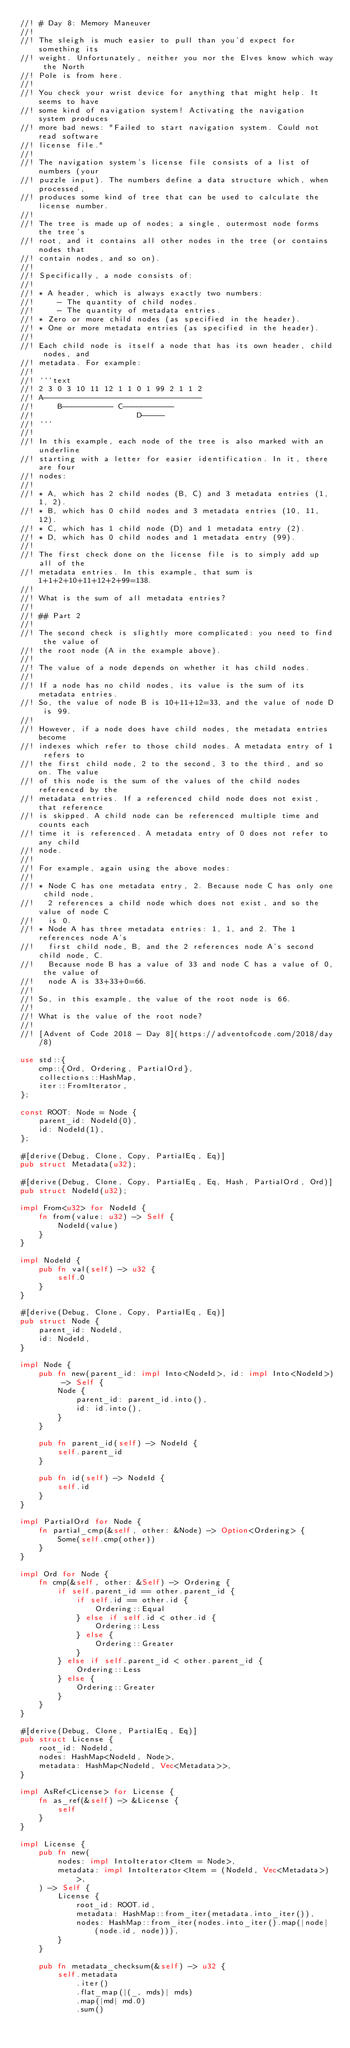<code> <loc_0><loc_0><loc_500><loc_500><_Rust_>//! # Day 8: Memory Maneuver
//!
//! The sleigh is much easier to pull than you'd expect for something its
//! weight. Unfortunately, neither you nor the Elves know which way the North
//! Pole is from here.
//!
//! You check your wrist device for anything that might help. It seems to have
//! some kind of navigation system! Activating the navigation system produces
//! more bad news: "Failed to start navigation system. Could not read software
//! license file."
//!
//! The navigation system's license file consists of a list of numbers (your
//! puzzle input). The numbers define a data structure which, when processed,
//! produces some kind of tree that can be used to calculate the license number.
//!
//! The tree is made up of nodes; a single, outermost node forms the tree's
//! root, and it contains all other nodes in the tree (or contains nodes that
//! contain nodes, and so on).
//!
//! Specifically, a node consists of:
//!
//! * A header, which is always exactly two numbers:
//!     - The quantity of child nodes.
//!     - The quantity of metadata entries.
//! * Zero or more child nodes (as specified in the header).
//! * One or more metadata entries (as specified in the header).
//!
//! Each child node is itself a node that has its own header, child nodes, and
//! metadata. For example:
//!
//! ```text
//! 2 3 0 3 10 11 12 1 1 0 1 99 2 1 1 2
//! A----------------------------------
//!     B----------- C-----------
//!                      D-----
//! ```
//!
//! In this example, each node of the tree is also marked with an underline
//! starting with a letter for easier identification. In it, there are four
//! nodes:
//!
//! * A, which has 2 child nodes (B, C) and 3 metadata entries (1, 1, 2).
//! * B, which has 0 child nodes and 3 metadata entries (10, 11, 12).
//! * C, which has 1 child node (D) and 1 metadata entry (2).
//! * D, which has 0 child nodes and 1 metadata entry (99).
//!
//! The first check done on the license file is to simply add up all of the
//! metadata entries. In this example, that sum is 1+1+2+10+11+12+2+99=138.
//!
//! What is the sum of all metadata entries?
//!
//! ## Part 2
//!
//! The second check is slightly more complicated: you need to find the value of
//! the root node (A in the example above).
//!
//! The value of a node depends on whether it has child nodes.
//!
//! If a node has no child nodes, its value is the sum of its metadata entries.
//! So, the value of node B is 10+11+12=33, and the value of node D is 99.
//!
//! However, if a node does have child nodes, the metadata entries become
//! indexes which refer to those child nodes. A metadata entry of 1 refers to
//! the first child node, 2 to the second, 3 to the third, and so on. The value
//! of this node is the sum of the values of the child nodes referenced by the
//! metadata entries. If a referenced child node does not exist, that reference
//! is skipped. A child node can be referenced multiple time and counts each
//! time it is referenced. A metadata entry of 0 does not refer to any child
//! node.
//!
//! For example, again using the above nodes:
//!
//! * Node C has one metadata entry, 2. Because node C has only one child node,
//!   2 references a child node which does not exist, and so the value of node C
//!   is 0.
//! * Node A has three metadata entries: 1, 1, and 2. The 1 references node A's
//!   first child node, B, and the 2 references node A's second child node, C.
//!   Because node B has a value of 33 and node C has a value of 0, the value of
//!   node A is 33+33+0=66.
//!
//! So, in this example, the value of the root node is 66.
//!
//! What is the value of the root node?
//!
//! [Advent of Code 2018 - Day 8](https://adventofcode.com/2018/day/8)

use std::{
    cmp::{Ord, Ordering, PartialOrd},
    collections::HashMap,
    iter::FromIterator,
};

const ROOT: Node = Node {
    parent_id: NodeId(0),
    id: NodeId(1),
};

#[derive(Debug, Clone, Copy, PartialEq, Eq)]
pub struct Metadata(u32);

#[derive(Debug, Clone, Copy, PartialEq, Eq, Hash, PartialOrd, Ord)]
pub struct NodeId(u32);

impl From<u32> for NodeId {
    fn from(value: u32) -> Self {
        NodeId(value)
    }
}

impl NodeId {
    pub fn val(self) -> u32 {
        self.0
    }
}

#[derive(Debug, Clone, Copy, PartialEq, Eq)]
pub struct Node {
    parent_id: NodeId,
    id: NodeId,
}

impl Node {
    pub fn new(parent_id: impl Into<NodeId>, id: impl Into<NodeId>) -> Self {
        Node {
            parent_id: parent_id.into(),
            id: id.into(),
        }
    }

    pub fn parent_id(self) -> NodeId {
        self.parent_id
    }

    pub fn id(self) -> NodeId {
        self.id
    }
}

impl PartialOrd for Node {
    fn partial_cmp(&self, other: &Node) -> Option<Ordering> {
        Some(self.cmp(other))
    }
}

impl Ord for Node {
    fn cmp(&self, other: &Self) -> Ordering {
        if self.parent_id == other.parent_id {
            if self.id == other.id {
                Ordering::Equal
            } else if self.id < other.id {
                Ordering::Less
            } else {
                Ordering::Greater
            }
        } else if self.parent_id < other.parent_id {
            Ordering::Less
        } else {
            Ordering::Greater
        }
    }
}

#[derive(Debug, Clone, PartialEq, Eq)]
pub struct License {
    root_id: NodeId,
    nodes: HashMap<NodeId, Node>,
    metadata: HashMap<NodeId, Vec<Metadata>>,
}

impl AsRef<License> for License {
    fn as_ref(&self) -> &License {
        self
    }
}

impl License {
    pub fn new(
        nodes: impl IntoIterator<Item = Node>,
        metadata: impl IntoIterator<Item = (NodeId, Vec<Metadata>)>,
    ) -> Self {
        License {
            root_id: ROOT.id,
            metadata: HashMap::from_iter(metadata.into_iter()),
            nodes: HashMap::from_iter(nodes.into_iter().map(|node| (node.id, node))),
        }
    }

    pub fn metadata_checksum(&self) -> u32 {
        self.metadata
            .iter()
            .flat_map(|(_, mds)| mds)
            .map(|md| md.0)
            .sum()</code> 